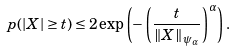<formula> <loc_0><loc_0><loc_500><loc_500>\ p ( | X | \geq t ) \leq 2 \exp \left ( - \left ( \frac { t } { \| X \| _ { \psi _ { \alpha } } } \right ) ^ { \alpha } \right ) .</formula> 